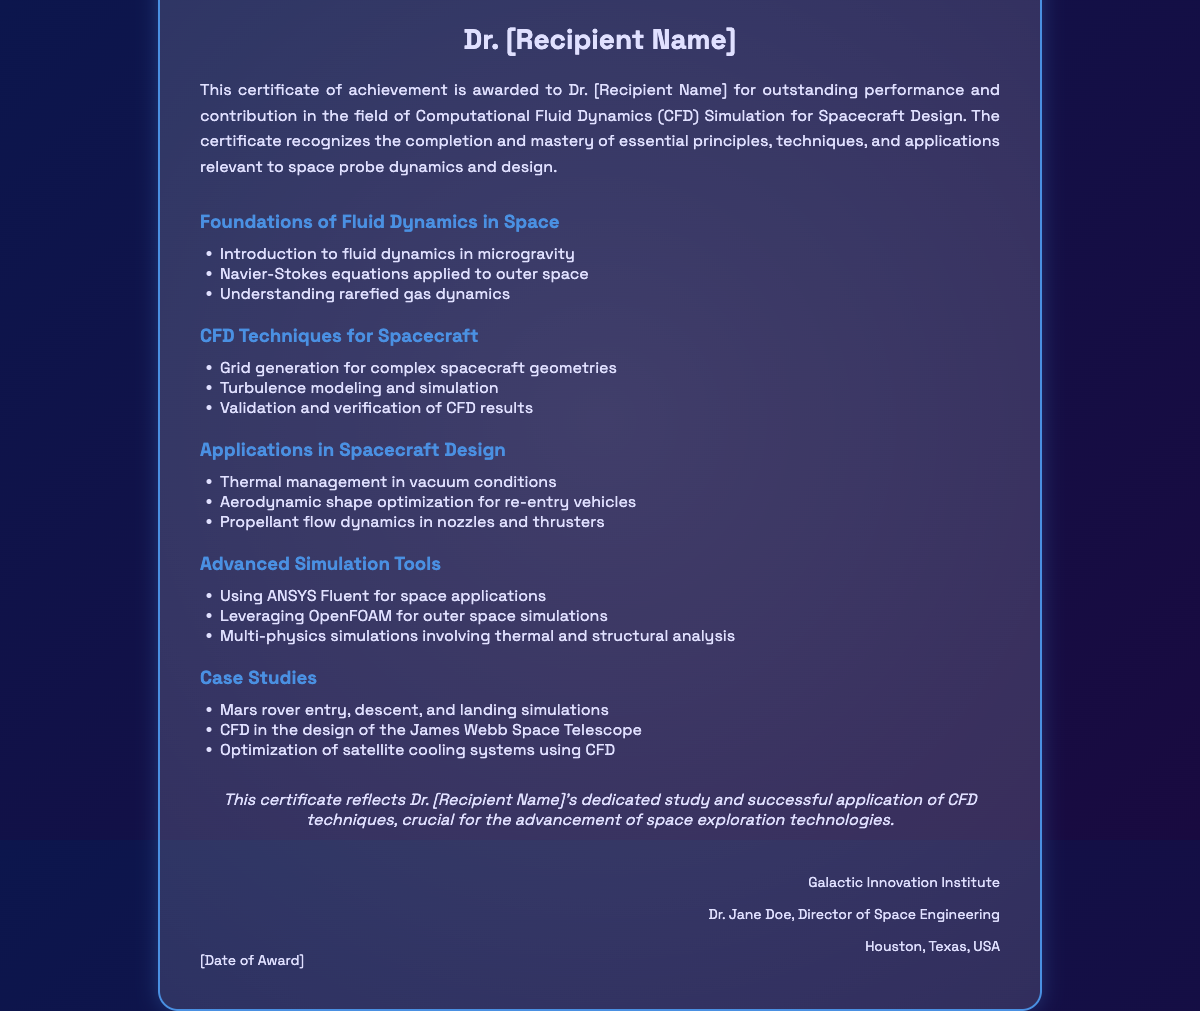What is the title of the certificate? The title of the certificate indicates the subject matter that it covers, which is "Certificate of Achievement in Computational Fluid Dynamics Simulation for Spacecraft Design."
Answer: Certificate of Achievement in Computational Fluid Dynamics Simulation for Spacecraft Design Who is the recipient of the certificate? The recipient's name is indicated under the recipient section and is placeholder text for the actual recipient's name, which will be filled in.
Answer: Dr. [Recipient Name] What is the first topic covered in the course components? The first topic listed under course components provides insight into the foundational knowledge required, which is "Foundations of Fluid Dynamics in Space."
Answer: Foundations of Fluid Dynamics in Space Which organization issued the certificate? The issuer's information is present in the footer section of the certificate, indicating the organization that awarded it.
Answer: Galactic Innovation Institute Who is the director mentioned in the issuer's information? The director mentioned in the issuer's information highlights the authority behind the certificate, showcasing an important figure in the organization.
Answer: Dr. Jane Doe What date is the certificate awarded? The date of award is a placeholder meant to be replaced with the actual award date, indicating when the achievement was recognized.
Answer: [Date of Award] What is the focus of the case studies listed in the document? The case studies section highlights real-world applications and examples of CFD techniques in space missions, indicating practical relevance.
Answer: Mars rover entry, descent, and landing simulations What type of CFD tools are mentioned as advanced simulation tools? The document lists specific tools used in CFD simulation for space applications, which demonstrate the technological resources employed in the studies.
Answer: ANSYS Fluent, OpenFOAM Which component involves validation and verification of results? This component focuses on critical aspects of CFD application, ensuring that simulations produce reliable results, integral to scientific studies.
Answer: CFD Techniques for Spacecraft 